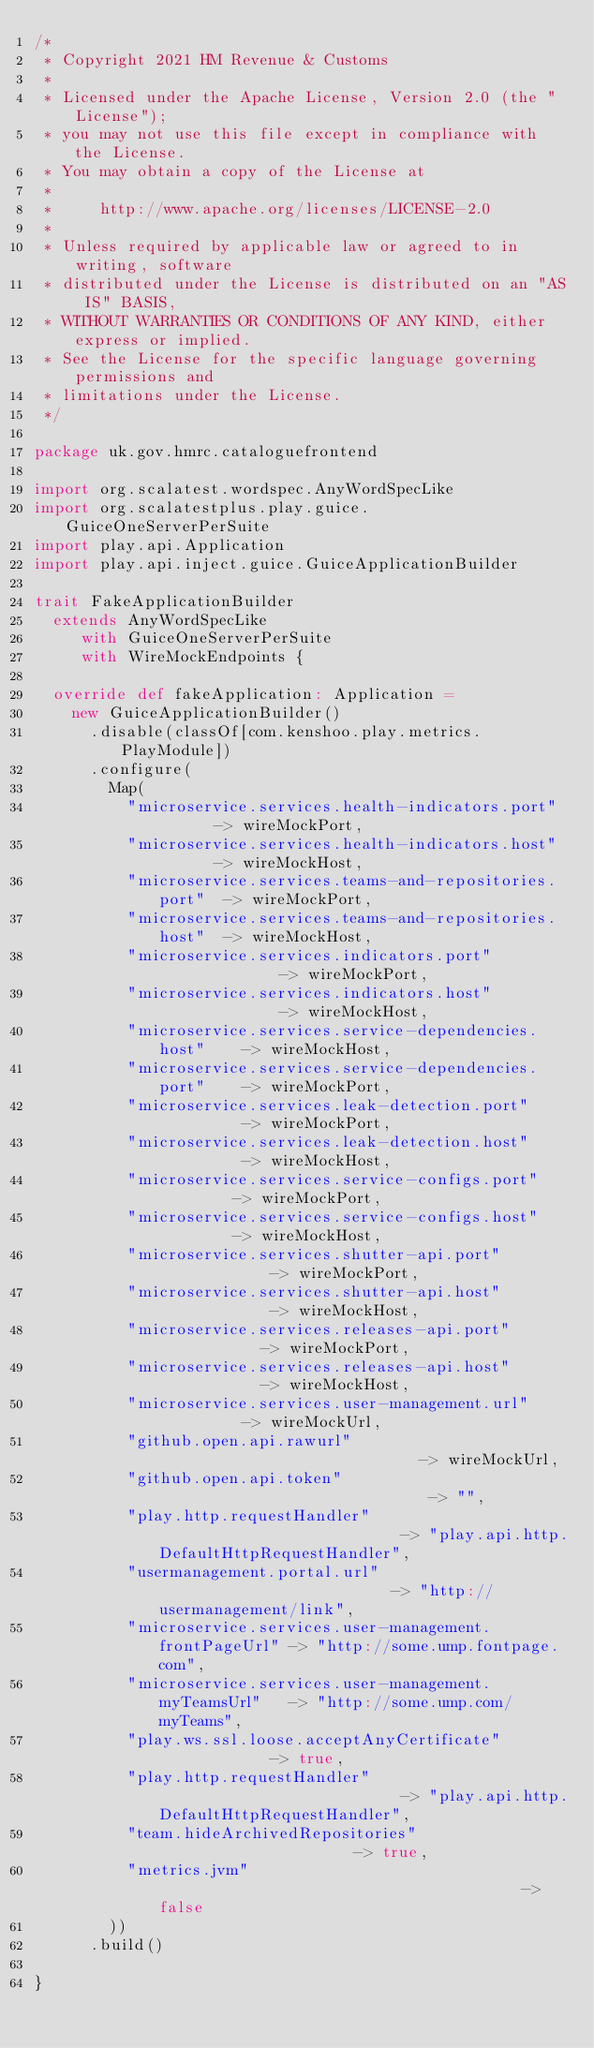Convert code to text. <code><loc_0><loc_0><loc_500><loc_500><_Scala_>/*
 * Copyright 2021 HM Revenue & Customs
 *
 * Licensed under the Apache License, Version 2.0 (the "License");
 * you may not use this file except in compliance with the License.
 * You may obtain a copy of the License at
 *
 *     http://www.apache.org/licenses/LICENSE-2.0
 *
 * Unless required by applicable law or agreed to in writing, software
 * distributed under the License is distributed on an "AS IS" BASIS,
 * WITHOUT WARRANTIES OR CONDITIONS OF ANY KIND, either express or implied.
 * See the License for the specific language governing permissions and
 * limitations under the License.
 */

package uk.gov.hmrc.cataloguefrontend

import org.scalatest.wordspec.AnyWordSpecLike
import org.scalatestplus.play.guice.GuiceOneServerPerSuite
import play.api.Application
import play.api.inject.guice.GuiceApplicationBuilder

trait FakeApplicationBuilder
  extends AnyWordSpecLike
     with GuiceOneServerPerSuite
     with WireMockEndpoints {

  override def fakeApplication: Application =
    new GuiceApplicationBuilder()
      .disable(classOf[com.kenshoo.play.metrics.PlayModule])
      .configure(
        Map(
          "microservice.services.health-indicators.port"       -> wireMockPort,
          "microservice.services.health-indicators.host"       -> wireMockHost,
          "microservice.services.teams-and-repositories.port"  -> wireMockPort,
          "microservice.services.teams-and-repositories.host"  -> wireMockHost,
          "microservice.services.indicators.port"              -> wireMockPort,
          "microservice.services.indicators.host"              -> wireMockHost,
          "microservice.services.service-dependencies.host"    -> wireMockHost,
          "microservice.services.service-dependencies.port"    -> wireMockPort,
          "microservice.services.leak-detection.port"          -> wireMockPort,
          "microservice.services.leak-detection.host"          -> wireMockHost,
          "microservice.services.service-configs.port"         -> wireMockPort,
          "microservice.services.service-configs.host"         -> wireMockHost,
          "microservice.services.shutter-api.port"             -> wireMockPort,
          "microservice.services.shutter-api.host"             -> wireMockHost,
          "microservice.services.releases-api.port"            -> wireMockPort,
          "microservice.services.releases-api.host"            -> wireMockHost,
          "microservice.services.user-management.url"          -> wireMockUrl,
          "github.open.api.rawurl"                             -> wireMockUrl,
          "github.open.api.token"                              -> "",
          "play.http.requestHandler"                           -> "play.api.http.DefaultHttpRequestHandler",
          "usermanagement.portal.url"                          -> "http://usermanagement/link",
          "microservice.services.user-management.frontPageUrl" -> "http://some.ump.fontpage.com",
          "microservice.services.user-management.myTeamsUrl"   -> "http://some.ump.com/myTeams",
          "play.ws.ssl.loose.acceptAnyCertificate"             -> true,
          "play.http.requestHandler"                           -> "play.api.http.DefaultHttpRequestHandler",
          "team.hideArchivedRepositories"                      -> true,
          "metrics.jvm"                                        -> false
        ))
      .build()

}
</code> 